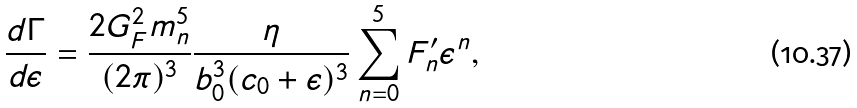<formula> <loc_0><loc_0><loc_500><loc_500>\frac { d \Gamma } { d \epsilon } = \frac { 2 G ^ { 2 } _ { F } m ^ { 5 } _ { n } } { ( 2 \pi ) ^ { 3 } } \frac { \eta } { b ^ { 3 } _ { 0 } ( c _ { 0 } + \epsilon ) ^ { 3 } } \sum ^ { 5 } _ { n = 0 } F ^ { \prime } _ { n } \epsilon ^ { n } ,</formula> 